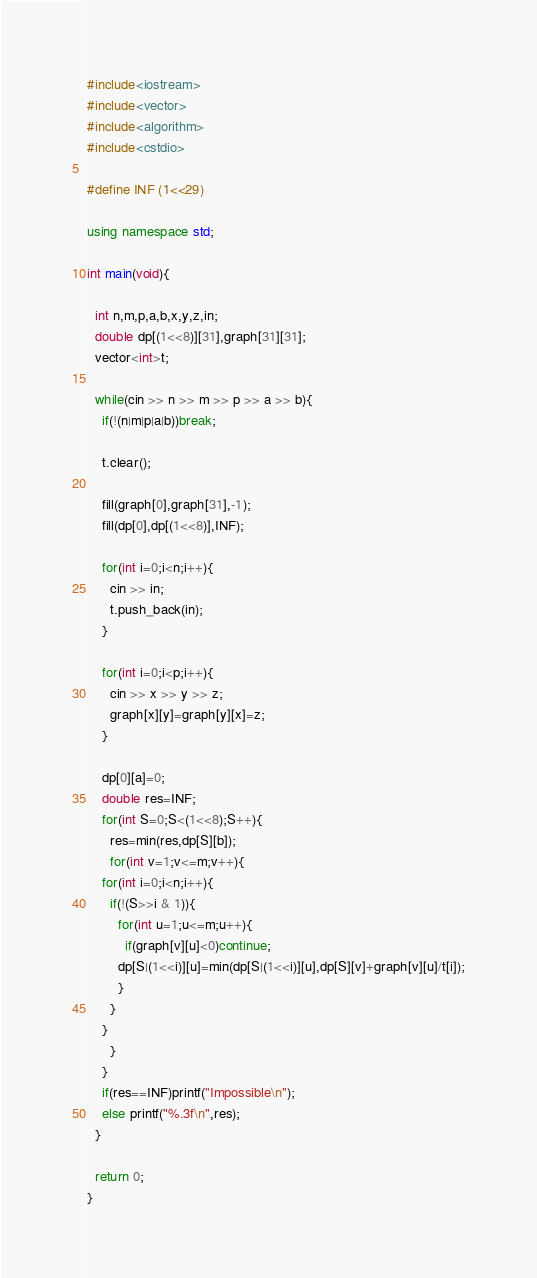<code> <loc_0><loc_0><loc_500><loc_500><_C++_>#include<iostream>
#include<vector>
#include<algorithm>
#include<cstdio>

#define INF (1<<29)
 
using namespace std;
 
int main(void){
  
  int n,m,p,a,b,x,y,z,in;
  double dp[(1<<8)][31],graph[31][31];
  vector<int>t;
  
  while(cin >> n >> m >> p >> a >> b){
    if(!(n|m|p|a|b))break;
    
    t.clear();
    
    fill(graph[0],graph[31],-1);
    fill(dp[0],dp[(1<<8)],INF);

    for(int i=0;i<n;i++){
      cin >> in;
      t.push_back(in);
    }
    
    for(int i=0;i<p;i++){
      cin >> x >> y >> z;
      graph[x][y]=graph[y][x]=z;
    }
    
    dp[0][a]=0;
    double res=INF;
    for(int S=0;S<(1<<8);S++){
      res=min(res,dp[S][b]);
      for(int v=1;v<=m;v++){
	for(int i=0;i<n;i++){
	  if(!(S>>i & 1)){
	    for(int u=1;u<=m;u++){
	      if(graph[v][u]<0)continue;
		dp[S|(1<<i)][u]=min(dp[S|(1<<i)][u],dp[S][v]+graph[v][u]/t[i]);
	    }
	  }
	}
      }
    }
    if(res==INF)printf("Impossible\n");
    else printf("%.3f\n",res);
  }
  
  return 0;
}</code> 